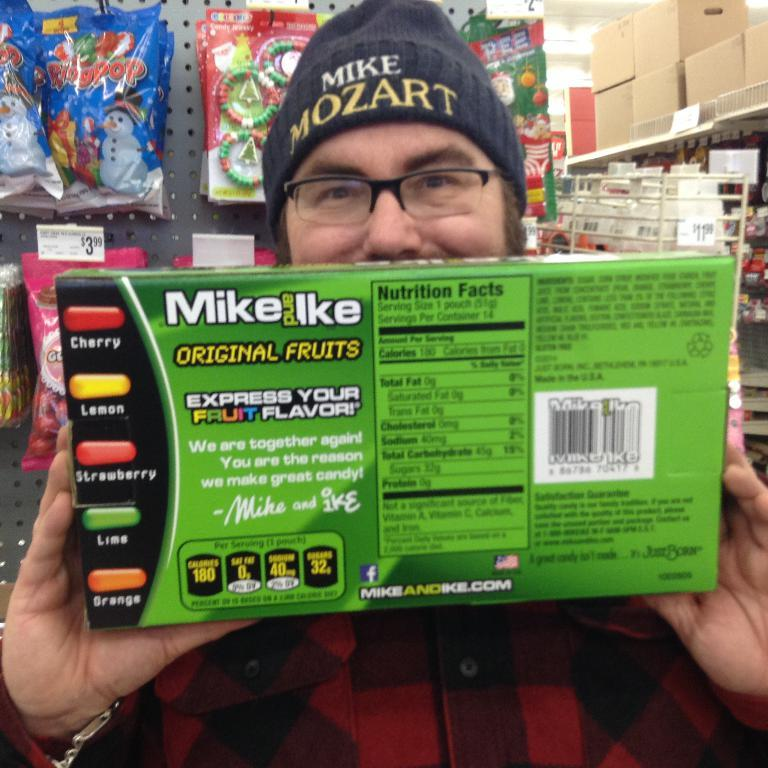What is the main subject in the foreground of the picture? There is a man in the foreground of the picture. What is the man wearing? The man is wearing a red shirt. What is the man holding in his hand? The man is holding a box in his hand. What can be seen in the background of the image? There are packets, a rack, boxes, and the ceiling visible in the background of the image. What type of road can be seen in the background of the image? There is no road visible in the image; the background consists of packets, a rack, boxes, and the ceiling. 